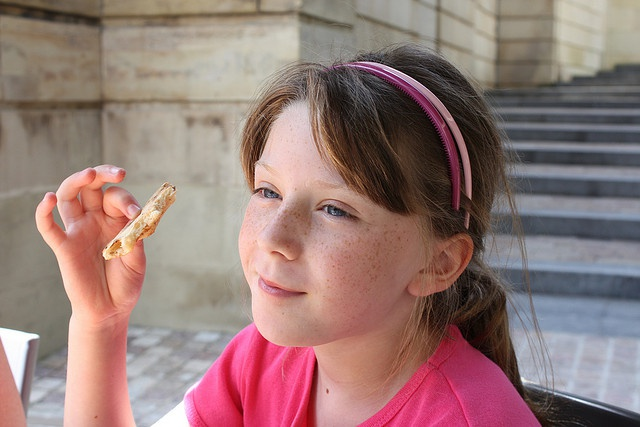Describe the objects in this image and their specific colors. I can see people in gray, brown, black, lightpink, and maroon tones and pizza in gray, tan, and ivory tones in this image. 